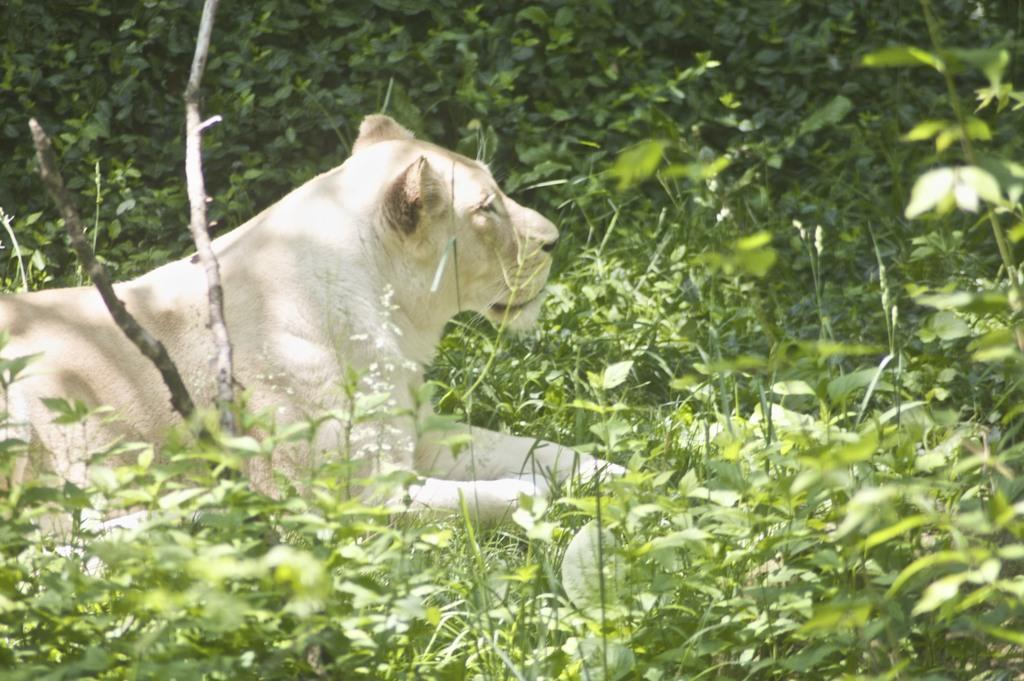What type of living organisms can be seen in the image? Plants can be seen in the image. What is the main subject in the center of the image? There is an animal sitting in the center of the image. Where is the queen sitting on her throne in the image? There is no queen or throne present in the image. What type of rod is being used by the animal in the image? There is no rod visible in the image, and the animal is not using any tool or object. 